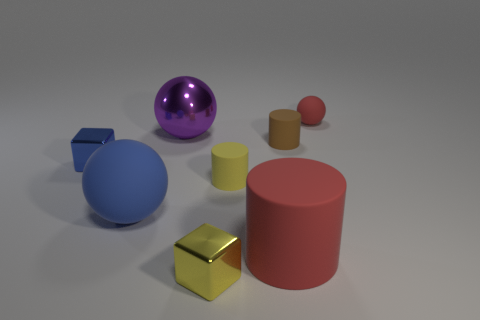Subtract all small brown matte cylinders. How many cylinders are left? 2 Add 1 green shiny things. How many objects exist? 9 Subtract all brown cylinders. How many cylinders are left? 2 Add 2 tiny shiny objects. How many tiny shiny objects are left? 4 Add 3 red rubber cylinders. How many red rubber cylinders exist? 4 Subtract 1 blue cubes. How many objects are left? 7 Subtract all cylinders. How many objects are left? 5 Subtract 1 cubes. How many cubes are left? 1 Subtract all green cylinders. Subtract all cyan cubes. How many cylinders are left? 3 Subtract all brown blocks. How many purple spheres are left? 1 